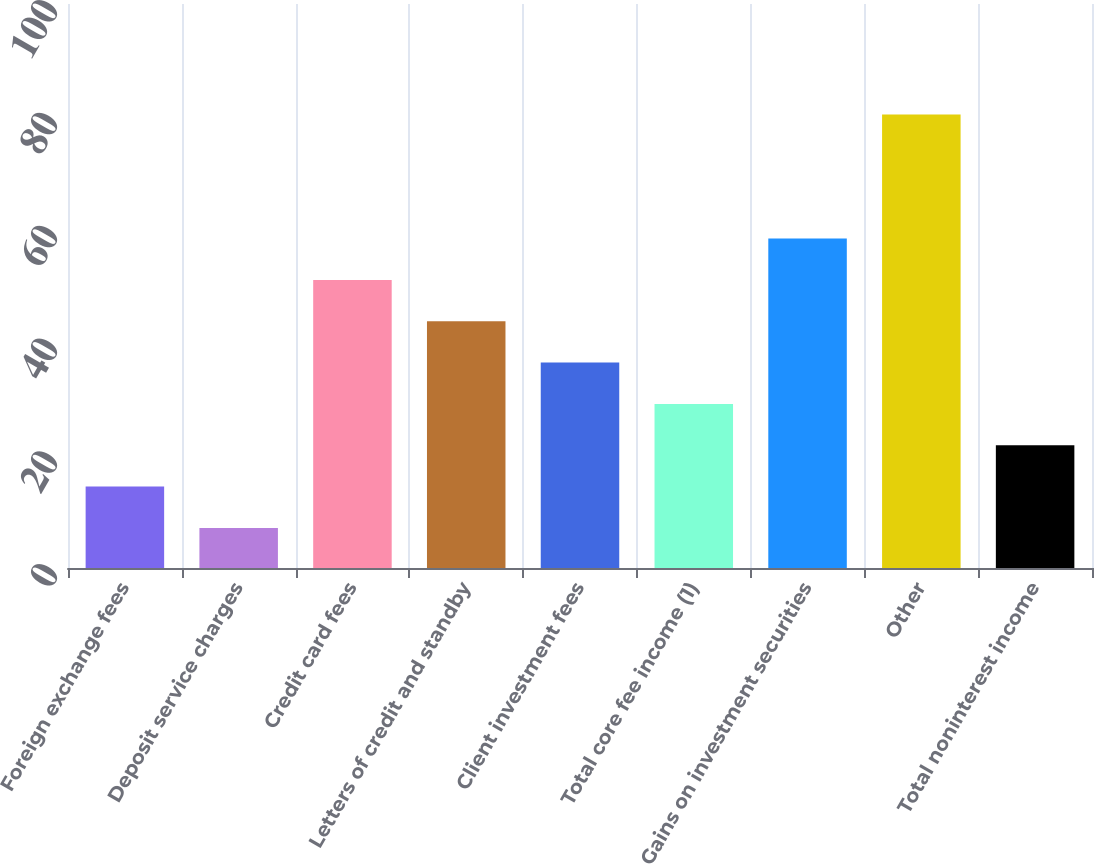Convert chart. <chart><loc_0><loc_0><loc_500><loc_500><bar_chart><fcel>Foreign exchange fees<fcel>Deposit service charges<fcel>Credit card fees<fcel>Letters of credit and standby<fcel>Client investment fees<fcel>Total core fee income (1)<fcel>Gains on investment securities<fcel>Other<fcel>Total noninterest income<nl><fcel>14.43<fcel>7.1<fcel>51.08<fcel>43.75<fcel>36.42<fcel>29.09<fcel>58.41<fcel>80.4<fcel>21.76<nl></chart> 